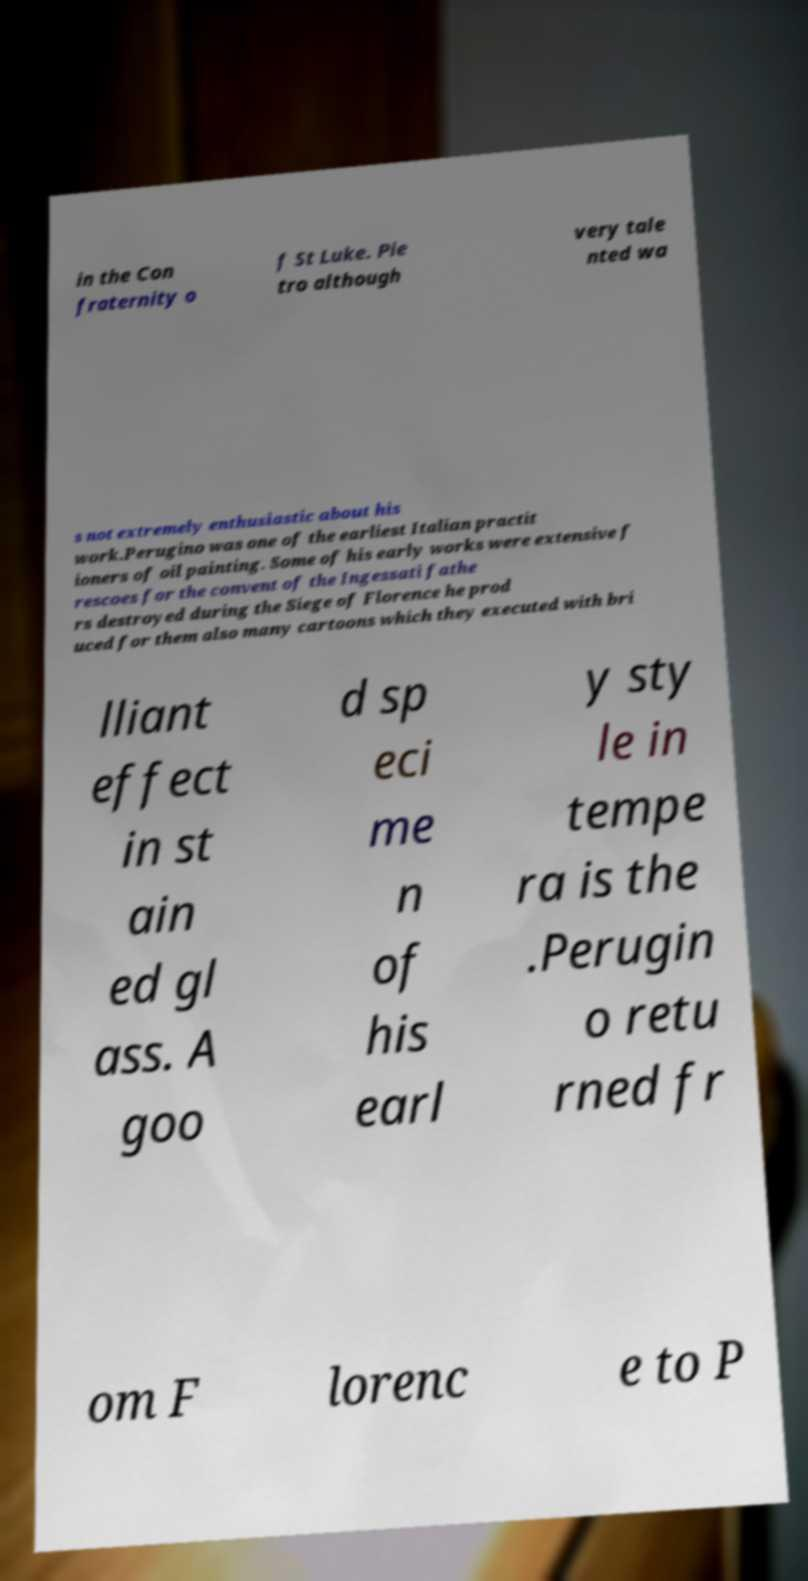I need the written content from this picture converted into text. Can you do that? in the Con fraternity o f St Luke. Pie tro although very tale nted wa s not extremely enthusiastic about his work.Perugino was one of the earliest Italian practit ioners of oil painting. Some of his early works were extensive f rescoes for the convent of the Ingessati fathe rs destroyed during the Siege of Florence he prod uced for them also many cartoons which they executed with bri lliant effect in st ain ed gl ass. A goo d sp eci me n of his earl y sty le in tempe ra is the .Perugin o retu rned fr om F lorenc e to P 